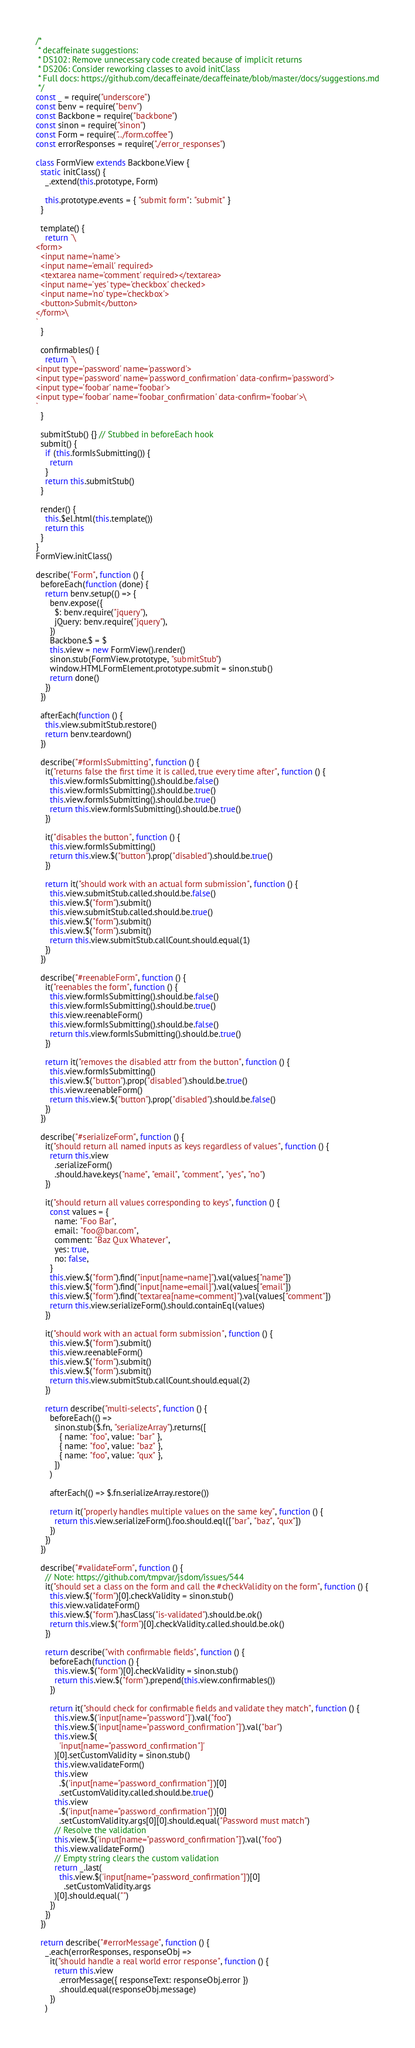Convert code to text. <code><loc_0><loc_0><loc_500><loc_500><_JavaScript_>/*
 * decaffeinate suggestions:
 * DS102: Remove unnecessary code created because of implicit returns
 * DS206: Consider reworking classes to avoid initClass
 * Full docs: https://github.com/decaffeinate/decaffeinate/blob/master/docs/suggestions.md
 */
const _ = require("underscore")
const benv = require("benv")
const Backbone = require("backbone")
const sinon = require("sinon")
const Form = require("../form.coffee")
const errorResponses = require("./error_responses")

class FormView extends Backbone.View {
  static initClass() {
    _.extend(this.prototype, Form)

    this.prototype.events = { "submit form": "submit" }
  }

  template() {
    return `\
<form>
  <input name='name'>
  <input name='email' required>
  <textarea name='comment' required></textarea>
  <input name='yes' type='checkbox' checked>
  <input name='no' type='checkbox'>
  <button>Submit</button>
</form>\
`
  }

  confirmables() {
    return `\
<input type='password' name='password'>
<input type='password' name='password_confirmation' data-confirm='password'>
<input type='foobar' name='foobar'>
<input type='foobar' name='foobar_confirmation' data-confirm='foobar'>\
`
  }

  submitStub() {} // Stubbed in beforeEach hook
  submit() {
    if (this.formIsSubmitting()) {
      return
    }
    return this.submitStub()
  }

  render() {
    this.$el.html(this.template())
    return this
  }
}
FormView.initClass()

describe("Form", function () {
  beforeEach(function (done) {
    return benv.setup(() => {
      benv.expose({
        $: benv.require("jquery"),
        jQuery: benv.require("jquery"),
      })
      Backbone.$ = $
      this.view = new FormView().render()
      sinon.stub(FormView.prototype, "submitStub")
      window.HTMLFormElement.prototype.submit = sinon.stub()
      return done()
    })
  })

  afterEach(function () {
    this.view.submitStub.restore()
    return benv.teardown()
  })

  describe("#formIsSubmitting", function () {
    it("returns false the first time it is called, true every time after", function () {
      this.view.formIsSubmitting().should.be.false()
      this.view.formIsSubmitting().should.be.true()
      this.view.formIsSubmitting().should.be.true()
      return this.view.formIsSubmitting().should.be.true()
    })

    it("disables the button", function () {
      this.view.formIsSubmitting()
      return this.view.$("button").prop("disabled").should.be.true()
    })

    return it("should work with an actual form submission", function () {
      this.view.submitStub.called.should.be.false()
      this.view.$("form").submit()
      this.view.submitStub.called.should.be.true()
      this.view.$("form").submit()
      this.view.$("form").submit()
      return this.view.submitStub.callCount.should.equal(1)
    })
  })

  describe("#reenableForm", function () {
    it("reenables the form", function () {
      this.view.formIsSubmitting().should.be.false()
      this.view.formIsSubmitting().should.be.true()
      this.view.reenableForm()
      this.view.formIsSubmitting().should.be.false()
      return this.view.formIsSubmitting().should.be.true()
    })

    return it("removes the disabled attr from the button", function () {
      this.view.formIsSubmitting()
      this.view.$("button").prop("disabled").should.be.true()
      this.view.reenableForm()
      return this.view.$("button").prop("disabled").should.be.false()
    })
  })

  describe("#serializeForm", function () {
    it("should return all named inputs as keys regardless of values", function () {
      return this.view
        .serializeForm()
        .should.have.keys("name", "email", "comment", "yes", "no")
    })

    it("should return all values corresponding to keys", function () {
      const values = {
        name: "Foo Bar",
        email: "foo@bar.com",
        comment: "Baz Qux Whatever",
        yes: true,
        no: false,
      }
      this.view.$("form").find("input[name=name]").val(values["name"])
      this.view.$("form").find("input[name=email]").val(values["email"])
      this.view.$("form").find("textarea[name=comment]").val(values["comment"])
      return this.view.serializeForm().should.containEql(values)
    })

    it("should work with an actual form submission", function () {
      this.view.$("form").submit()
      this.view.reenableForm()
      this.view.$("form").submit()
      this.view.$("form").submit()
      return this.view.submitStub.callCount.should.equal(2)
    })

    return describe("multi-selects", function () {
      beforeEach(() =>
        sinon.stub($.fn, "serializeArray").returns([
          { name: "foo", value: "bar" },
          { name: "foo", value: "baz" },
          { name: "foo", value: "qux" },
        ])
      )

      afterEach(() => $.fn.serializeArray.restore())

      return it("properly handles multiple values on the same key", function () {
        return this.view.serializeForm().foo.should.eql(["bar", "baz", "qux"])
      })
    })
  })

  describe("#validateForm", function () {
    // Note: https://github.com/tmpvar/jsdom/issues/544
    it("should set a class on the form and call the #checkValidity on the form", function () {
      this.view.$("form")[0].checkValidity = sinon.stub()
      this.view.validateForm()
      this.view.$("form").hasClass("is-validated").should.be.ok()
      return this.view.$("form")[0].checkValidity.called.should.be.ok()
    })

    return describe("with confirmable fields", function () {
      beforeEach(function () {
        this.view.$("form")[0].checkValidity = sinon.stub()
        return this.view.$("form").prepend(this.view.confirmables())
      })

      return it("should check for confirmable fields and validate they match", function () {
        this.view.$('input[name="password"]').val("foo")
        this.view.$('input[name="password_confirmation"]').val("bar")
        this.view.$(
          'input[name="password_confirmation"]'
        )[0].setCustomValidity = sinon.stub()
        this.view.validateForm()
        this.view
          .$('input[name="password_confirmation"]')[0]
          .setCustomValidity.called.should.be.true()
        this.view
          .$('input[name="password_confirmation"]')[0]
          .setCustomValidity.args[0][0].should.equal("Password must match")
        // Resolve the validation
        this.view.$('input[name="password_confirmation"]').val("foo")
        this.view.validateForm()
        // Empty string clears the custom validation
        return _.last(
          this.view.$('input[name="password_confirmation"]')[0]
            .setCustomValidity.args
        )[0].should.equal("")
      })
    })
  })

  return describe("#errorMessage", function () {
    _.each(errorResponses, responseObj =>
      it("should handle a real world error response", function () {
        return this.view
          .errorMessage({ responseText: responseObj.error })
          .should.equal(responseObj.message)
      })
    )
</code> 